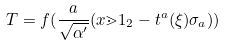Convert formula to latex. <formula><loc_0><loc_0><loc_500><loc_500>T = f ( \frac { a } { \sqrt { \alpha ^ { \prime } } } ( x \mathbb { m } { 1 } _ { 2 } - t ^ { a } ( \xi ) \sigma _ { a } ) )</formula> 